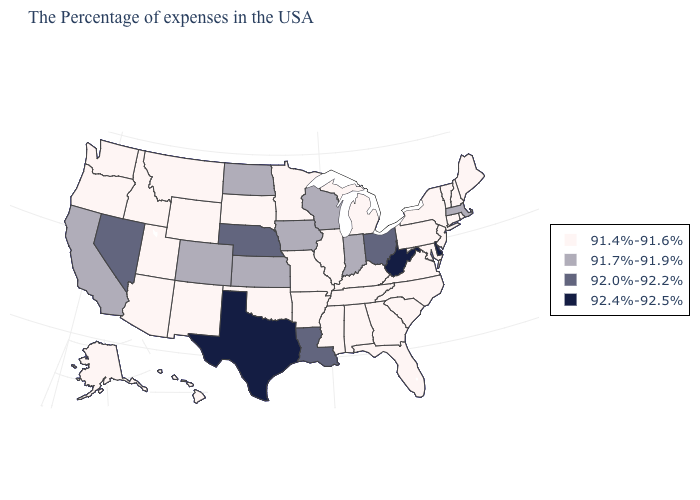Name the states that have a value in the range 91.4%-91.6%?
Write a very short answer. Maine, Rhode Island, New Hampshire, Vermont, Connecticut, New York, New Jersey, Maryland, Pennsylvania, Virginia, North Carolina, South Carolina, Florida, Georgia, Michigan, Kentucky, Alabama, Tennessee, Illinois, Mississippi, Missouri, Arkansas, Minnesota, Oklahoma, South Dakota, Wyoming, New Mexico, Utah, Montana, Arizona, Idaho, Washington, Oregon, Alaska, Hawaii. Among the states that border New Jersey , which have the lowest value?
Quick response, please. New York, Pennsylvania. What is the value of South Carolina?
Keep it brief. 91.4%-91.6%. Does Massachusetts have the lowest value in the Northeast?
Quick response, please. No. What is the highest value in states that border Pennsylvania?
Concise answer only. 92.4%-92.5%. What is the value of Nevada?
Short answer required. 92.0%-92.2%. Does Connecticut have the same value as North Dakota?
Quick response, please. No. Name the states that have a value in the range 92.4%-92.5%?
Write a very short answer. Delaware, West Virginia, Texas. What is the lowest value in the USA?
Concise answer only. 91.4%-91.6%. What is the value of North Carolina?
Short answer required. 91.4%-91.6%. Does the map have missing data?
Short answer required. No. Name the states that have a value in the range 91.4%-91.6%?
Be succinct. Maine, Rhode Island, New Hampshire, Vermont, Connecticut, New York, New Jersey, Maryland, Pennsylvania, Virginia, North Carolina, South Carolina, Florida, Georgia, Michigan, Kentucky, Alabama, Tennessee, Illinois, Mississippi, Missouri, Arkansas, Minnesota, Oklahoma, South Dakota, Wyoming, New Mexico, Utah, Montana, Arizona, Idaho, Washington, Oregon, Alaska, Hawaii. What is the lowest value in the MidWest?
Quick response, please. 91.4%-91.6%. Does Oklahoma have a lower value than New Jersey?
Short answer required. No. Name the states that have a value in the range 91.4%-91.6%?
Give a very brief answer. Maine, Rhode Island, New Hampshire, Vermont, Connecticut, New York, New Jersey, Maryland, Pennsylvania, Virginia, North Carolina, South Carolina, Florida, Georgia, Michigan, Kentucky, Alabama, Tennessee, Illinois, Mississippi, Missouri, Arkansas, Minnesota, Oklahoma, South Dakota, Wyoming, New Mexico, Utah, Montana, Arizona, Idaho, Washington, Oregon, Alaska, Hawaii. 